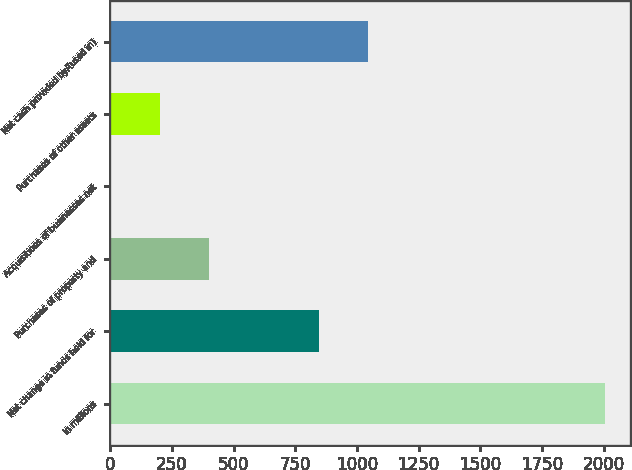Convert chart. <chart><loc_0><loc_0><loc_500><loc_500><bar_chart><fcel>In millions<fcel>Net change in funds held for<fcel>Purchases of property and<fcel>Acquisitions of businesses net<fcel>Purchases of other assets<fcel>Net cash provided by/(used in)<nl><fcel>2006<fcel>844.8<fcel>401.76<fcel>0.7<fcel>201.23<fcel>1045.33<nl></chart> 